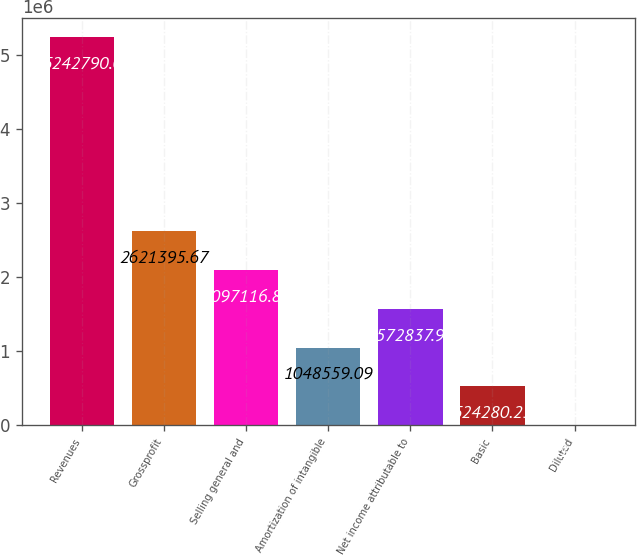Convert chart. <chart><loc_0><loc_0><loc_500><loc_500><bar_chart><fcel>Revenues<fcel>Grossprofit<fcel>Selling general and<fcel>Amortization of intangible<fcel>Net income attributable to<fcel>Basic<fcel>Diluted<nl><fcel>5.24279e+06<fcel>2.6214e+06<fcel>2.09712e+06<fcel>1.04856e+06<fcel>1.57284e+06<fcel>524280<fcel>1.37<nl></chart> 